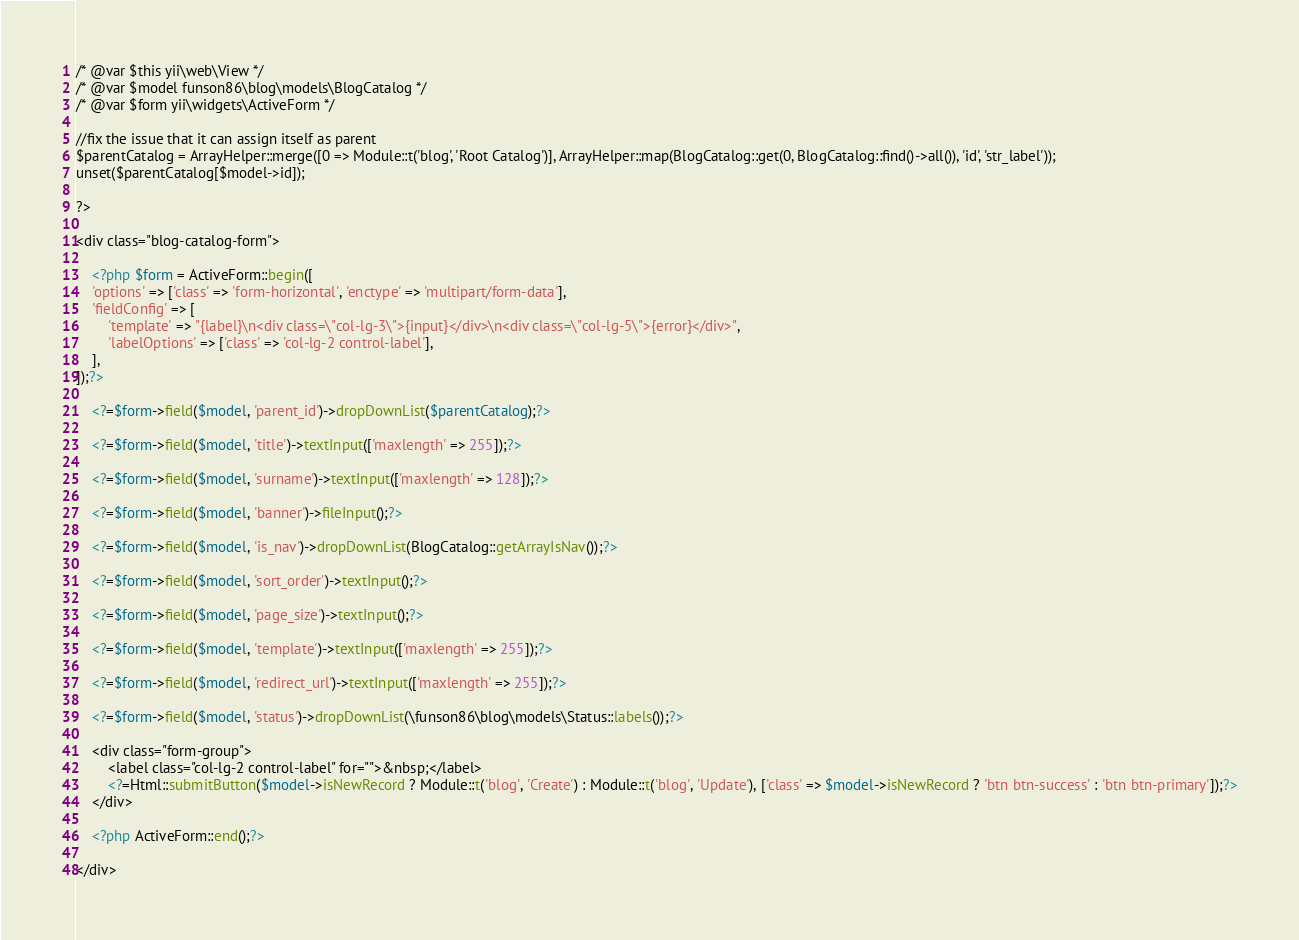<code> <loc_0><loc_0><loc_500><loc_500><_PHP_>/* @var $this yii\web\View */
/* @var $model funson86\blog\models\BlogCatalog */
/* @var $form yii\widgets\ActiveForm */

//fix the issue that it can assign itself as parent
$parentCatalog = ArrayHelper::merge([0 => Module::t('blog', 'Root Catalog')], ArrayHelper::map(BlogCatalog::get(0, BlogCatalog::find()->all()), 'id', 'str_label'));
unset($parentCatalog[$model->id]);

?>

<div class="blog-catalog-form">

    <?php $form = ActiveForm::begin([
    'options' => ['class' => 'form-horizontal', 'enctype' => 'multipart/form-data'],
    'fieldConfig' => [
        'template' => "{label}\n<div class=\"col-lg-3\">{input}</div>\n<div class=\"col-lg-5\">{error}</div>",
        'labelOptions' => ['class' => 'col-lg-2 control-label'],
    ],
]);?>

    <?=$form->field($model, 'parent_id')->dropDownList($parentCatalog);?>

    <?=$form->field($model, 'title')->textInput(['maxlength' => 255]);?>

    <?=$form->field($model, 'surname')->textInput(['maxlength' => 128]);?>

    <?=$form->field($model, 'banner')->fileInput();?>

    <?=$form->field($model, 'is_nav')->dropDownList(BlogCatalog::getArrayIsNav());?>

    <?=$form->field($model, 'sort_order')->textInput();?>

    <?=$form->field($model, 'page_size')->textInput();?>

    <?=$form->field($model, 'template')->textInput(['maxlength' => 255]);?>

    <?=$form->field($model, 'redirect_url')->textInput(['maxlength' => 255]);?>

    <?=$form->field($model, 'status')->dropDownList(\funson86\blog\models\Status::labels());?>

    <div class="form-group">
        <label class="col-lg-2 control-label" for="">&nbsp;</label>
        <?=Html::submitButton($model->isNewRecord ? Module::t('blog', 'Create') : Module::t('blog', 'Update'), ['class' => $model->isNewRecord ? 'btn btn-success' : 'btn btn-primary']);?>
    </div>

    <?php ActiveForm::end();?>

</div>
</code> 